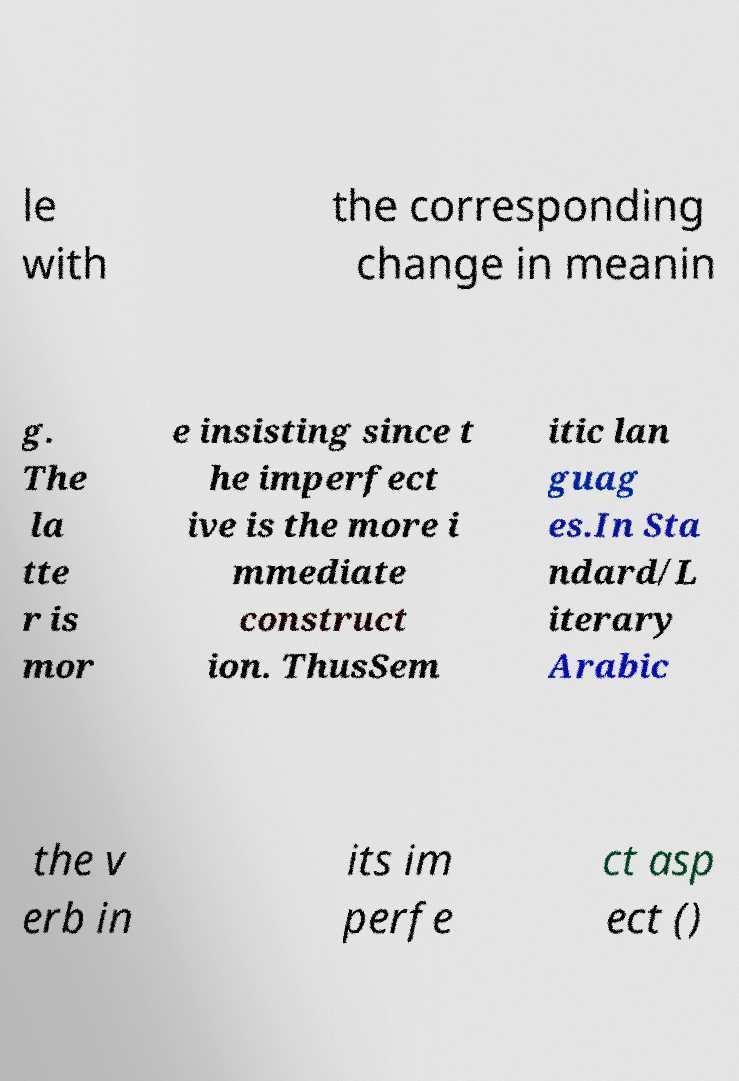Can you accurately transcribe the text from the provided image for me? le with the corresponding change in meanin g. The la tte r is mor e insisting since t he imperfect ive is the more i mmediate construct ion. ThusSem itic lan guag es.In Sta ndard/L iterary Arabic the v erb in its im perfe ct asp ect () 